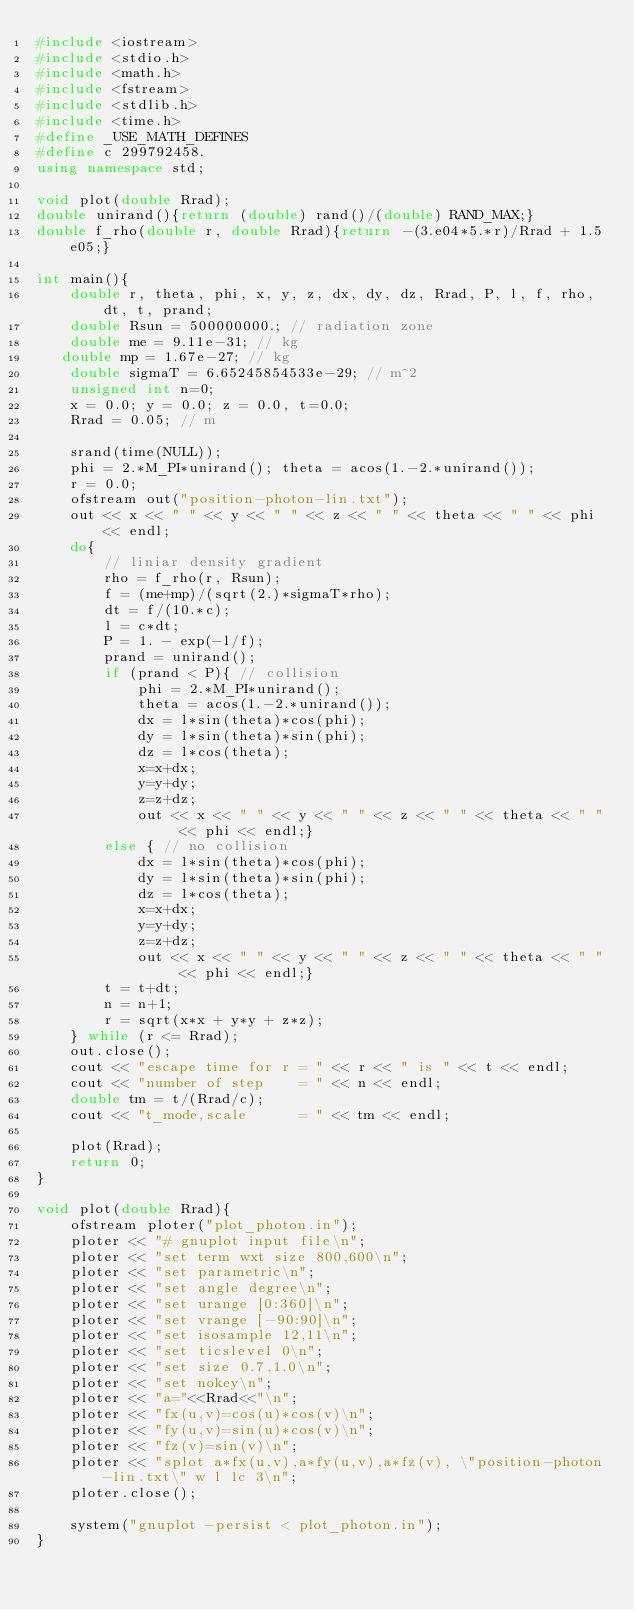Convert code to text. <code><loc_0><loc_0><loc_500><loc_500><_C++_>#include <iostream>
#include <stdio.h>
#include <math.h>
#include <fstream>
#include <stdlib.h>
#include <time.h>
#define _USE_MATH_DEFINES
#define c 299792458.
using namespace std;

void plot(double Rrad);
double unirand(){return (double) rand()/(double) RAND_MAX;}
double f_rho(double r, double Rrad){return -(3.e04*5.*r)/Rrad + 1.5e05;}

int main(){
    double r, theta, phi, x, y, z, dx, dy, dz, Rrad, P, l, f, rho, dt, t, prand;
    double Rsun = 500000000.; // radiation zone
    double me = 9.11e-31; // kg
   double mp = 1.67e-27; // kg
    double sigmaT = 6.65245854533e-29; // m^2
    unsigned int n=0;
    x = 0.0; y = 0.0; z = 0.0, t=0.0;
    Rrad = 0.05; // m 

    srand(time(NULL));
    phi = 2.*M_PI*unirand(); theta = acos(1.-2.*unirand());
    r = 0.0;
    ofstream out("position-photon-lin.txt");
    out << x << " " << y << " " << z << " " << theta << " " << phi << endl;
    do{
        // liniar density gradient
        rho = f_rho(r, Rsun);
        f = (me+mp)/(sqrt(2.)*sigmaT*rho);
        dt = f/(10.*c);
        l = c*dt;
        P = 1. - exp(-l/f);
        prand = unirand();
        if (prand < P){ // collision
            phi = 2.*M_PI*unirand(); 
            theta = acos(1.-2.*unirand());
            dx = l*sin(theta)*cos(phi); 
            dy = l*sin(theta)*sin(phi); 
            dz = l*cos(theta);
            x=x+dx; 
            y=y+dy; 
            z=z+dz;
            out << x << " " << y << " " << z << " " << theta << " " << phi << endl;}
        else { // no collision
            dx = l*sin(theta)*cos(phi); 
            dy = l*sin(theta)*sin(phi); 
            dz = l*cos(theta);
            x=x+dx; 
            y=y+dy; 
            z=z+dz;
            out << x << " " << y << " " << z << " " << theta << " " << phi << endl;}
        t = t+dt;
        n = n+1;
        r = sqrt(x*x + y*y + z*z);
    } while (r <= Rrad);
    out.close();
    cout << "escape time for r = " << r << " is " << t << endl;
    cout << "number of step    = " << n << endl;
    double tm = t/(Rrad/c);
    cout << "t_mode,scale      = " << tm << endl;
    
    plot(Rrad);
    return 0;
}

void plot(double Rrad){
    ofstream ploter("plot_photon.in");
    ploter << "# gnuplot input file\n";
    ploter << "set term wxt size 800,600\n";
    ploter << "set parametric\n";
    ploter << "set angle degree\n";
    ploter << "set urange [0:360]\n";
    ploter << "set vrange [-90:90]\n";
    ploter << "set isosample 12,11\n";
    ploter << "set ticslevel 0\n";
    ploter << "set size 0.7,1.0\n";
    ploter << "set nokey\n";
    ploter << "a="<<Rrad<<"\n";
    ploter << "fx(u,v)=cos(u)*cos(v)\n";
    ploter << "fy(u,v)=sin(u)*cos(v)\n";
    ploter << "fz(v)=sin(v)\n";
    ploter << "splot a*fx(u,v),a*fy(u,v),a*fz(v), \"position-photon-lin.txt\" w l lc 3\n";
    ploter.close();

    system("gnuplot -persist < plot_photon.in");
}
</code> 